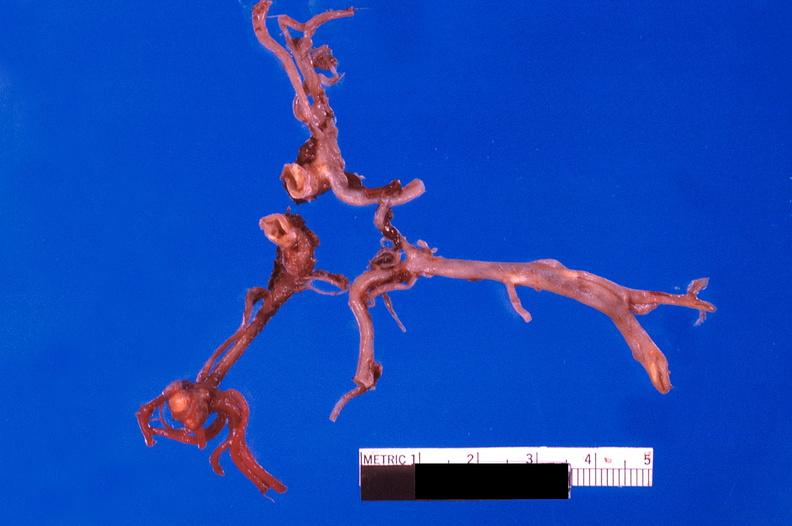s subdiaphragmatic abscess present?
Answer the question using a single word or phrase. No 